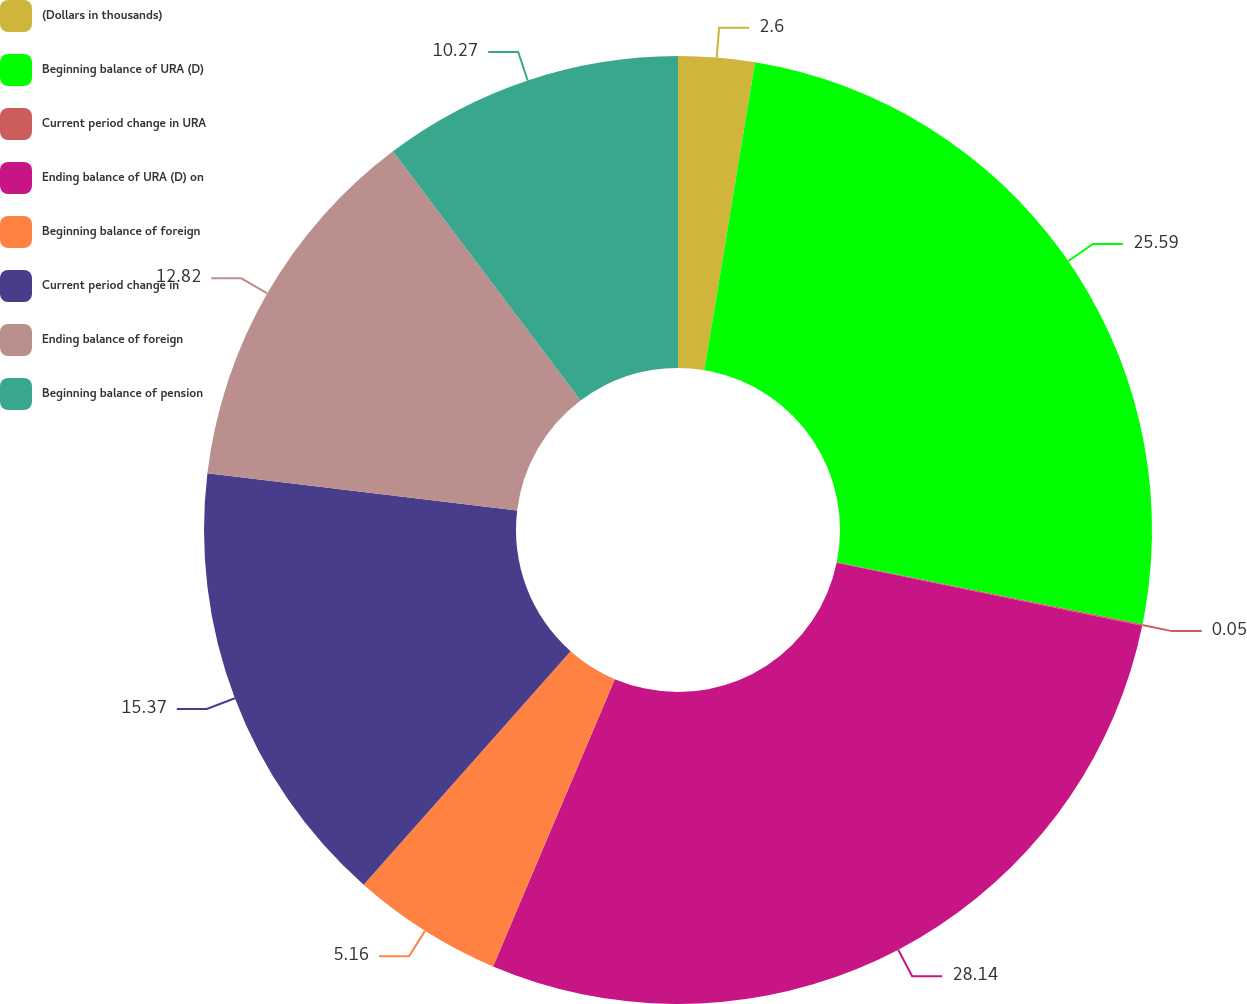<chart> <loc_0><loc_0><loc_500><loc_500><pie_chart><fcel>(Dollars in thousands)<fcel>Beginning balance of URA (D)<fcel>Current period change in URA<fcel>Ending balance of URA (D) on<fcel>Beginning balance of foreign<fcel>Current period change in<fcel>Ending balance of foreign<fcel>Beginning balance of pension<nl><fcel>2.6%<fcel>25.59%<fcel>0.05%<fcel>28.14%<fcel>5.16%<fcel>15.37%<fcel>12.82%<fcel>10.27%<nl></chart> 